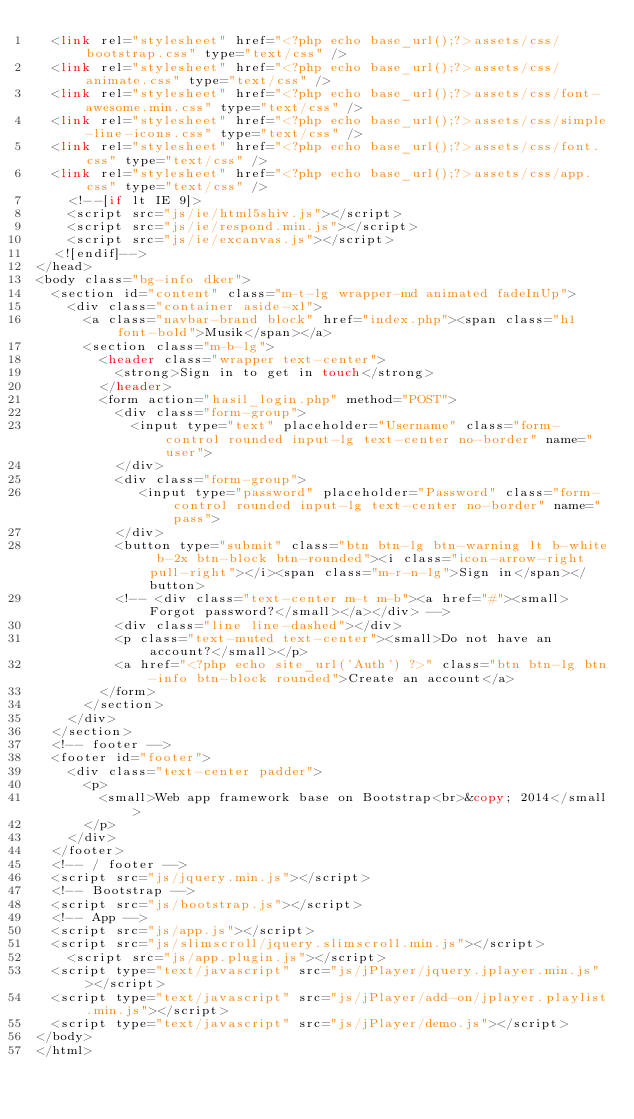Convert code to text. <code><loc_0><loc_0><loc_500><loc_500><_PHP_>  <link rel="stylesheet" href="<?php echo base_url();?>assets/css/bootstrap.css" type="text/css" />
  <link rel="stylesheet" href="<?php echo base_url();?>assets/css/animate.css" type="text/css" />
  <link rel="stylesheet" href="<?php echo base_url();?>assets/css/font-awesome.min.css" type="text/css" />
  <link rel="stylesheet" href="<?php echo base_url();?>assets/css/simple-line-icons.css" type="text/css" />
  <link rel="stylesheet" href="<?php echo base_url();?>assets/css/font.css" type="text/css" />
  <link rel="stylesheet" href="<?php echo base_url();?>assets/css/app.css" type="text/css" />  
    <!--[if lt IE 9]>
    <script src="js/ie/html5shiv.js"></script>
    <script src="js/ie/respond.min.js"></script>
    <script src="js/ie/excanvas.js"></script>
  <![endif]-->
</head>
<body class="bg-info dker">
  <section id="content" class="m-t-lg wrapper-md animated fadeInUp">    
    <div class="container aside-xl">
      <a class="navbar-brand block" href="index.php"><span class="h1 font-bold">Musik</span></a>
      <section class="m-b-lg">
        <header class="wrapper text-center">
          <strong>Sign in to get in touch</strong>
        </header>
        <form action="hasil_login.php" method="POST">
          <div class="form-group">
            <input type="text" placeholder="Username" class="form-control rounded input-lg text-center no-border" name="user">
          </div>
          <div class="form-group">
             <input type="password" placeholder="Password" class="form-control rounded input-lg text-center no-border" name="pass">
          </div>
          <button type="submit" class="btn btn-lg btn-warning lt b-white b-2x btn-block btn-rounded"><i class="icon-arrow-right pull-right"></i><span class="m-r-n-lg">Sign in</span></button>
          <!-- <div class="text-center m-t m-b"><a href="#"><small>Forgot password?</small></a></div> -->
          <div class="line line-dashed"></div>
          <p class="text-muted text-center"><small>Do not have an account?</small></p>
          <a href="<?php echo site_url('Auth') ?>" class="btn btn-lg btn-info btn-block rounded">Create an account</a>
        </form>
      </section>
    </div>
  </section>
  <!-- footer -->
  <footer id="footer">
    <div class="text-center padder">
      <p>
        <small>Web app framework base on Bootstrap<br>&copy; 2014</small>
      </p>
    </div>
  </footer>
  <!-- / footer -->
  <script src="js/jquery.min.js"></script>
  <!-- Bootstrap -->
  <script src="js/bootstrap.js"></script>
  <!-- App -->
  <script src="js/app.js"></script>  
  <script src="js/slimscroll/jquery.slimscroll.min.js"></script>
    <script src="js/app.plugin.js"></script>
  <script type="text/javascript" src="js/jPlayer/jquery.jplayer.min.js"></script>
  <script type="text/javascript" src="js/jPlayer/add-on/jplayer.playlist.min.js"></script>
  <script type="text/javascript" src="js/jPlayer/demo.js"></script>
</body>
</html></code> 